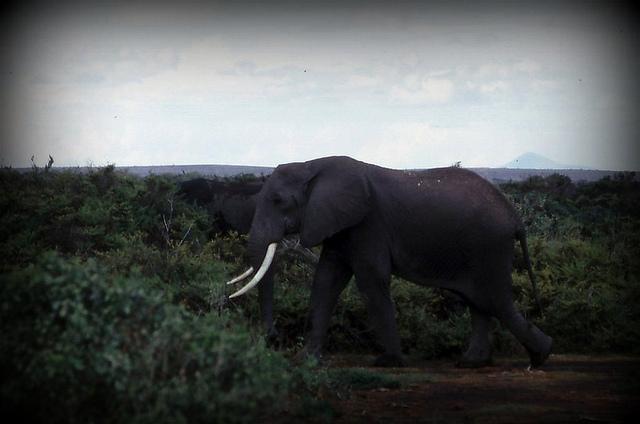How many birds are in this picture?
Give a very brief answer. 0. How many tusks are visible?
Give a very brief answer. 2. How many orange parts are there?
Give a very brief answer. 0. 